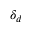<formula> <loc_0><loc_0><loc_500><loc_500>\delta _ { d }</formula> 